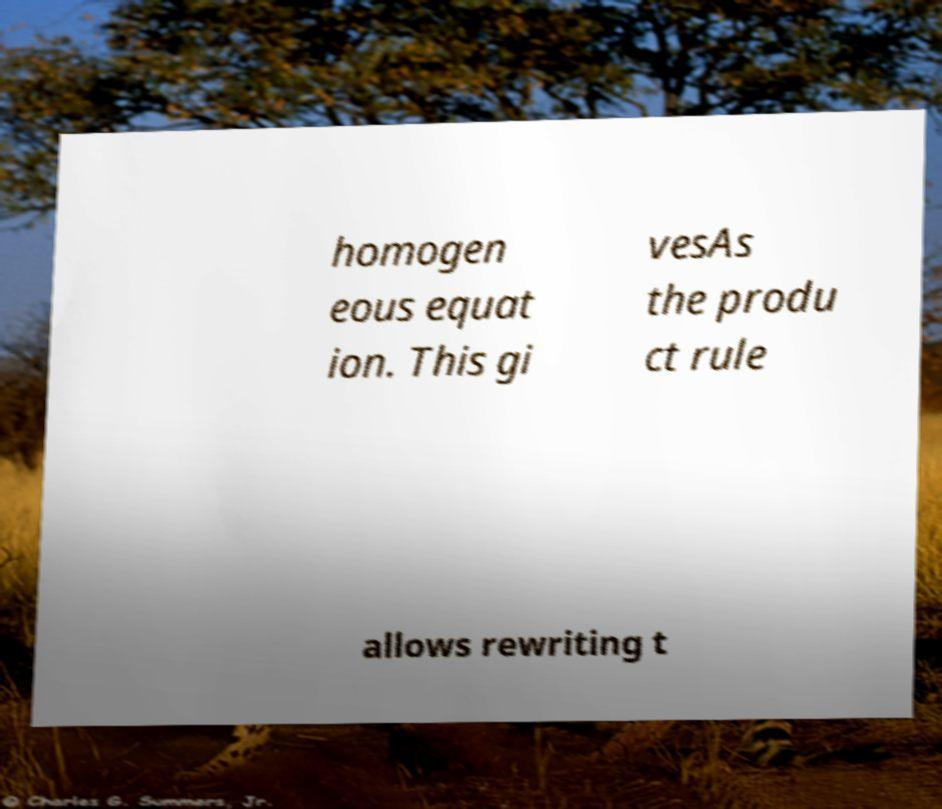There's text embedded in this image that I need extracted. Can you transcribe it verbatim? homogen eous equat ion. This gi vesAs the produ ct rule allows rewriting t 